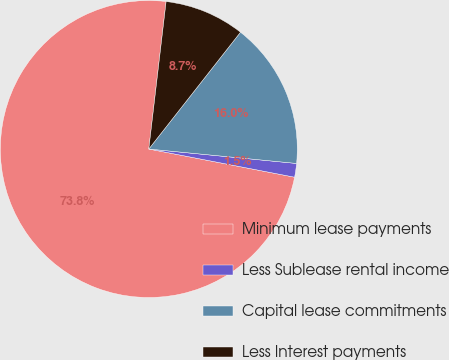<chart> <loc_0><loc_0><loc_500><loc_500><pie_chart><fcel>Minimum lease payments<fcel>Less Sublease rental income<fcel>Capital lease commitments<fcel>Less Interest payments<nl><fcel>73.82%<fcel>1.49%<fcel>15.96%<fcel>8.73%<nl></chart> 